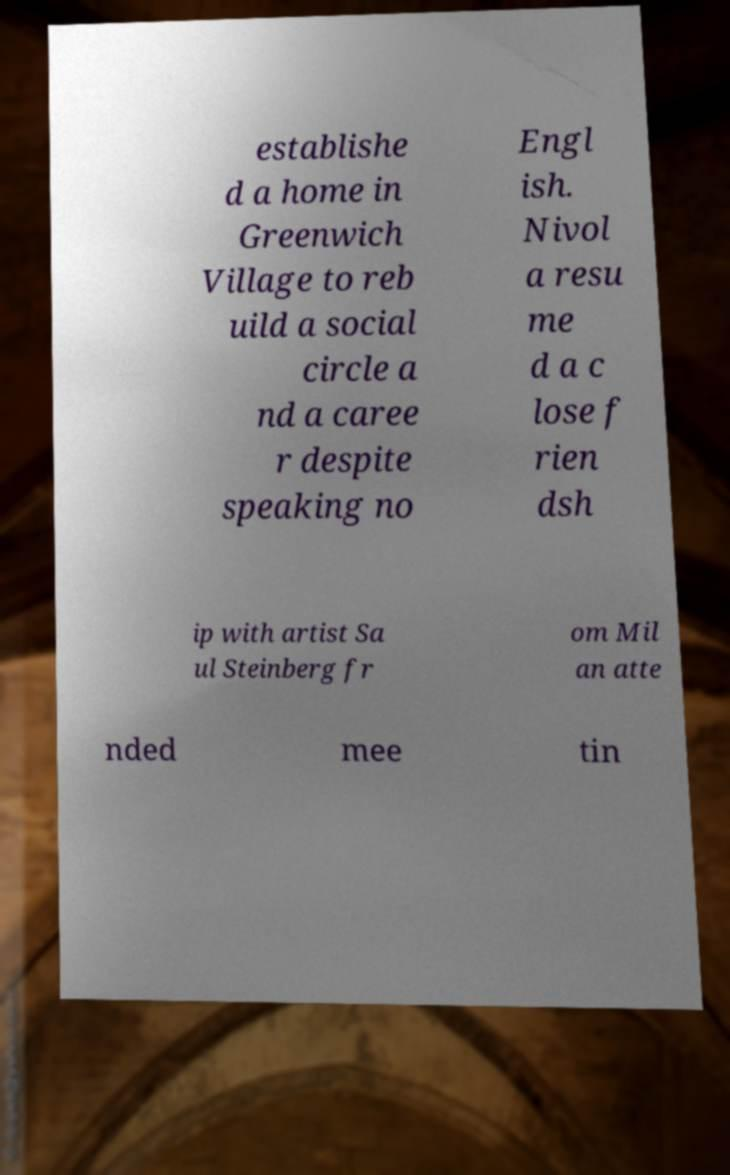I need the written content from this picture converted into text. Can you do that? establishe d a home in Greenwich Village to reb uild a social circle a nd a caree r despite speaking no Engl ish. Nivol a resu me d a c lose f rien dsh ip with artist Sa ul Steinberg fr om Mil an atte nded mee tin 